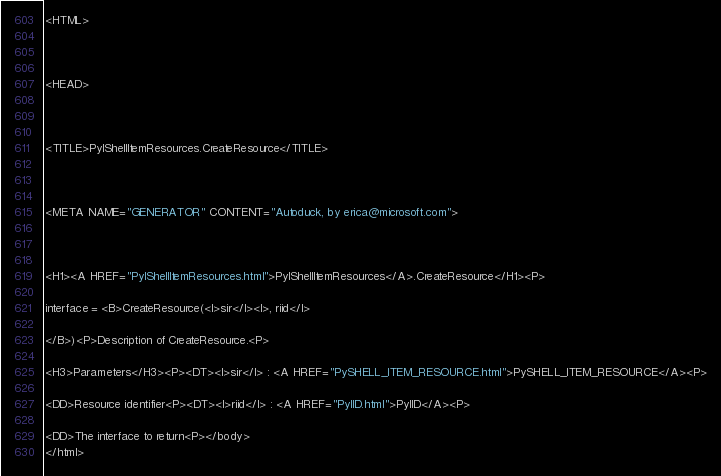Convert code to text. <code><loc_0><loc_0><loc_500><loc_500><_HTML_><HTML>



<HEAD>



<TITLE>PyIShellItemResources.CreateResource</TITLE>



<META NAME="GENERATOR" CONTENT="Autoduck, by erica@microsoft.com">



<H1><A HREF="PyIShellItemResources.html">PyIShellItemResources</A>.CreateResource</H1><P>

interface = <B>CreateResource(<I>sir</I><I>, riid</I>

</B>)<P>Description of CreateResource.<P>

<H3>Parameters</H3><P><DT><I>sir</I> : <A HREF="PySHELL_ITEM_RESOURCE.html">PySHELL_ITEM_RESOURCE</A><P>

<DD>Resource identifier<P><DT><I>riid</I> : <A HREF="PyIID.html">PyIID</A><P>

<DD>The interface to return<P></body>
</html></code> 